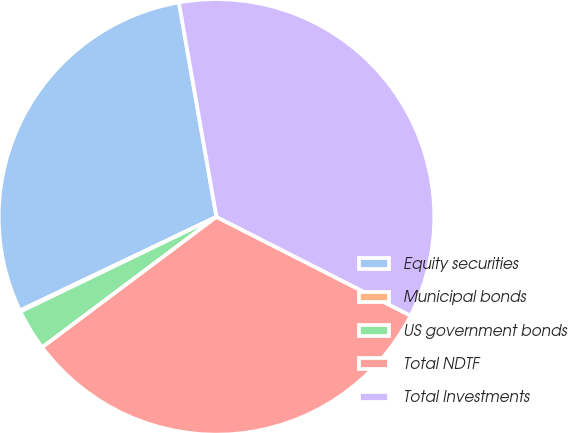Convert chart to OTSL. <chart><loc_0><loc_0><loc_500><loc_500><pie_chart><fcel>Equity securities<fcel>Municipal bonds<fcel>US government bonds<fcel>Total NDTF<fcel>Total Investments<nl><fcel>29.31%<fcel>0.09%<fcel>3.06%<fcel>32.28%<fcel>35.25%<nl></chart> 